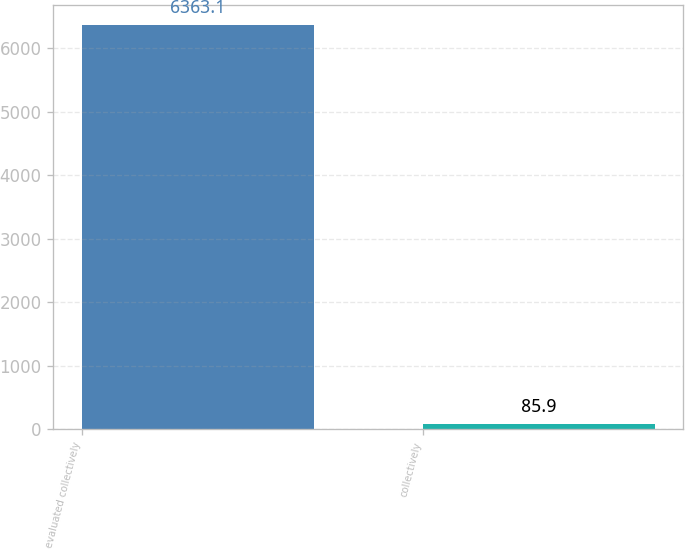<chart> <loc_0><loc_0><loc_500><loc_500><bar_chart><fcel>evaluated collectively<fcel>collectively<nl><fcel>6363.1<fcel>85.9<nl></chart> 